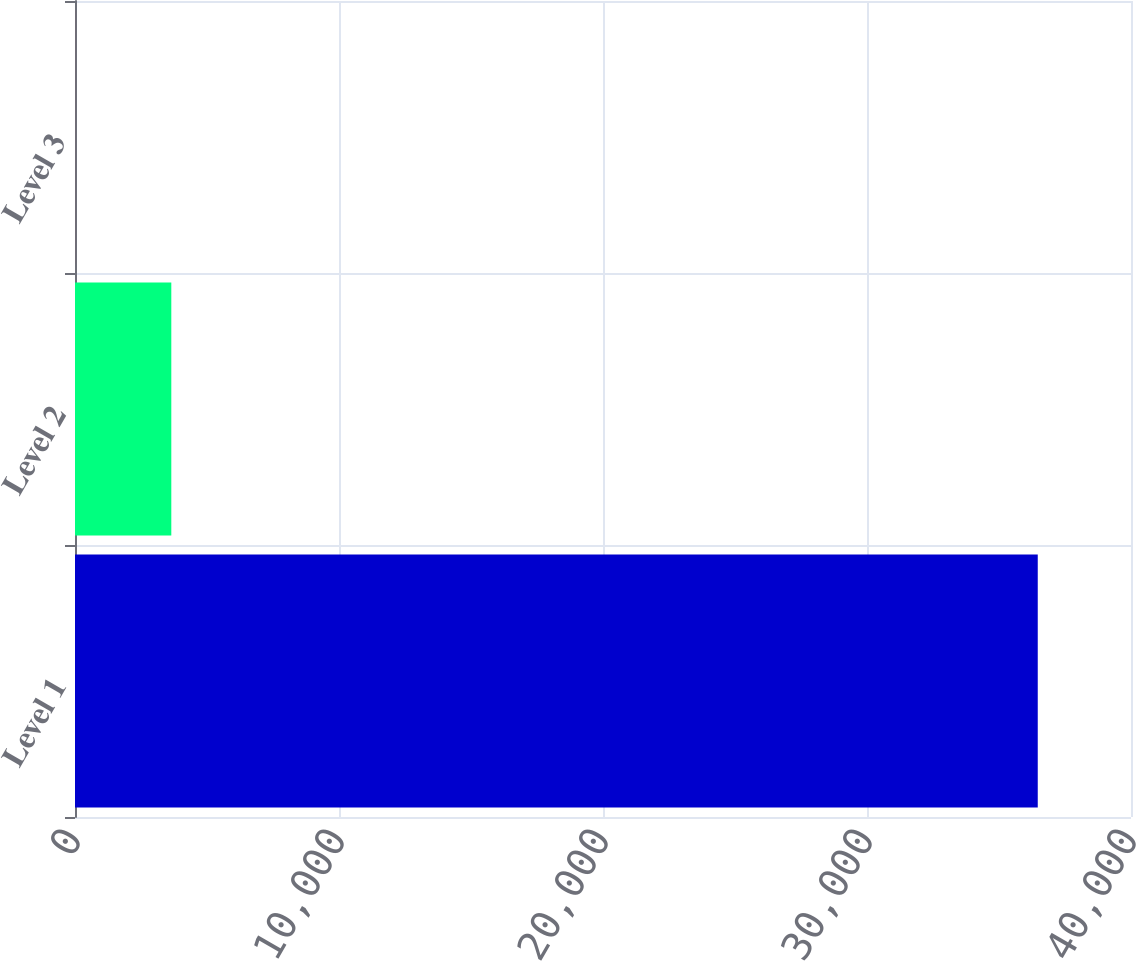Convert chart to OTSL. <chart><loc_0><loc_0><loc_500><loc_500><bar_chart><fcel>Level 1<fcel>Level 2<fcel>Level 3<nl><fcel>36468<fcel>3647.8<fcel>1.11<nl></chart> 